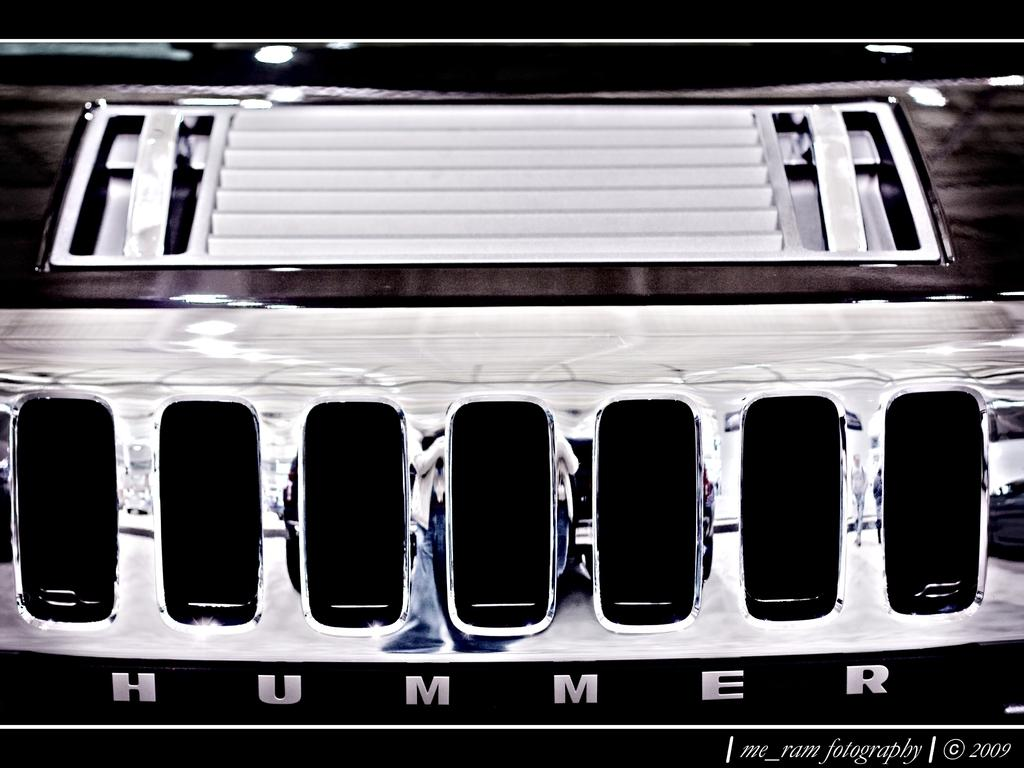What part of a car is shown in the image? The image depicts a car's bonnet. What type of needle is used to sew the rod onto the car's bonnet in the image? There is no needle or rod present in the image; it only shows a car's bonnet. Is there a pipe visible on the car's bonnet in the image? No, there is no pipe visible on the car's bonnet in the image. 